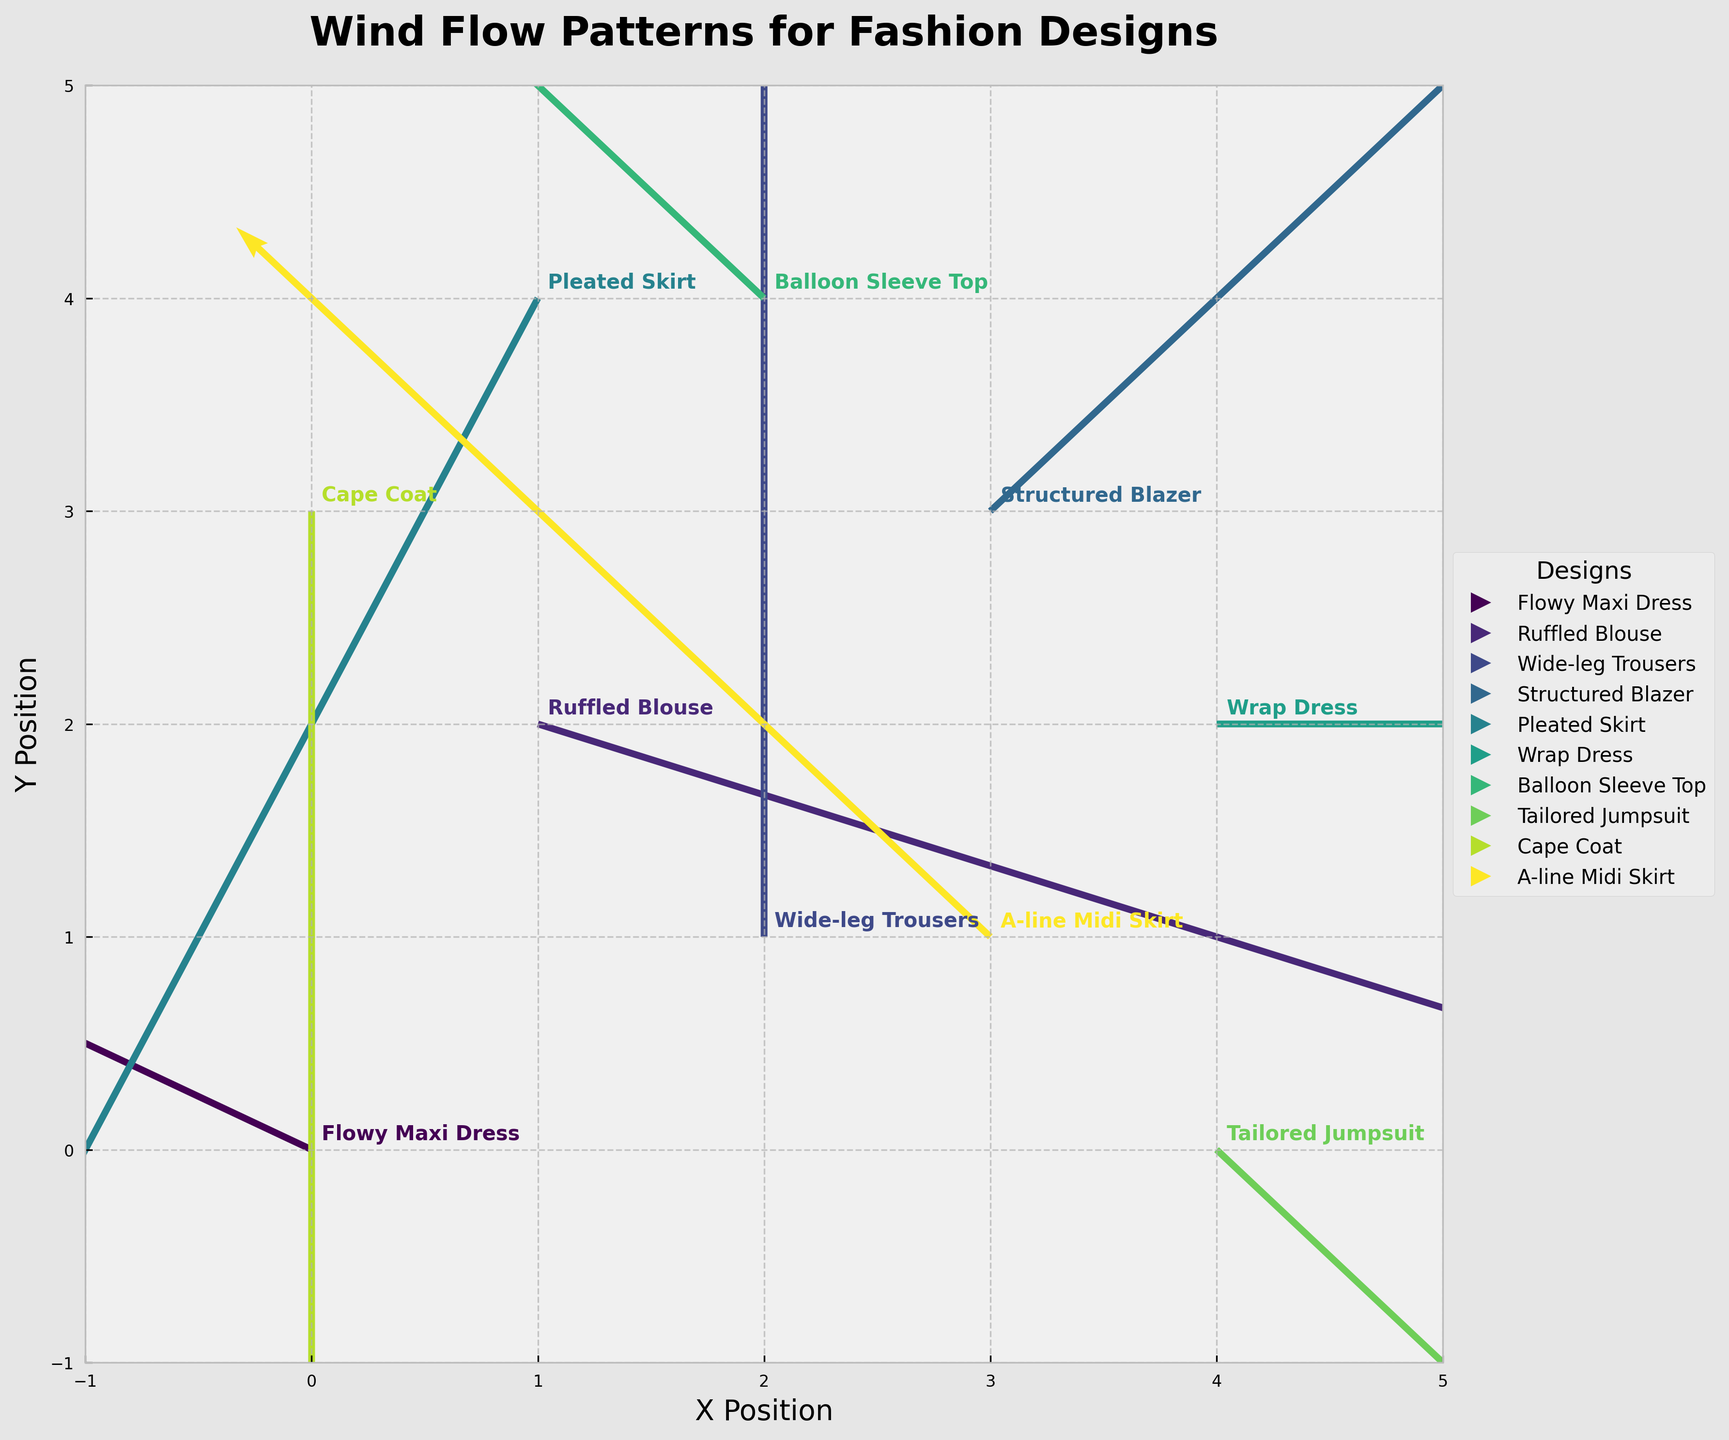Which design is located at the coordinates (1, 2)? The coordinates (1, 2) correspond to the position on the plot. Looking at this point, we see the "Ruffled Blouse" design annotated.
Answer: Ruffled Blouse How many different designs are displayed in the figure? The figure has annotated each design clearly. Counting these annotations shows there are 10 different designs displayed.
Answer: 10 What is the direction of the wind flow for the "Tailored Jumpsuit"? The quiver arrow for "Tailored Jumpsuit" has components (1, -1), indicating the wind flows to the right and downward.
Answer: Right and downward Which design experiences the strongest wind flow (based on vector length)? To find the strongest wind flow, we compare the magnitudes of the vectors. The magnitude is calculated using √(u^2 + v^2). The "Ruffled Blouse" with vector (3, -1) has the largest magnitude, √(3^2 + (-1)^2) = √10.
Answer: Ruffled Blouse What is the X and Y direction of the wind flow for the "Wide-leg Trousers"? The quiver arrow for "Wide-leg Trousers" is (0, 2). This means there is no wind flow in the X direction, and the wind flows upwards in the Y direction.
Answer: No X direction, Upward in Y direction Compare the wind flow directions of the "Flowy Maxi Dress" and "Balloon Sleeve Top". Who has stronger flows? "Flowy Maxi Dress" has vector (-2, 1) and "Balloon Sleeve Top" has vector (-2, 2). First, calculate their magnitudes: √((-2)^2 + 1^2) = √5 and √((-2)^2 + 2^2) = √8. So, "Balloon Sleeve Top" has a stronger wind flow.
Answer: Balloon Sleeve Top Which designs have a zero horizontal (x) component of wind flow? A zero horizontal component means u = 0. Checking the data: "Wide-leg Trousers" (0,2), "Cape Coat" (0, -2).
Answer: Wide-leg Trousers, Cape Coat Where is the "Pleated Skirt" located on the plot? "Pleated Skirt" is annotated at the coordinates (1, 4) on the plot.
Answer: (1, 4) What is the average vertical (y) component of the wind flow for all designs? Sum all vertical components and divide by the number of designs: 1 + (-1) + 2 + 1 + (-2) + 0 + 2 + (-1) + (-2) + 1 = 1. Average = 1 / 10 = 0.1.
Answer: 0.1 Which design has a wind flow direction completely in the horizontal axis? A flow direction completely in the horizontal axis will have a zero vertical (y) component. The "Wrap Dress" has the components (2, 0), indicating this case.
Answer: Wrap Dress 